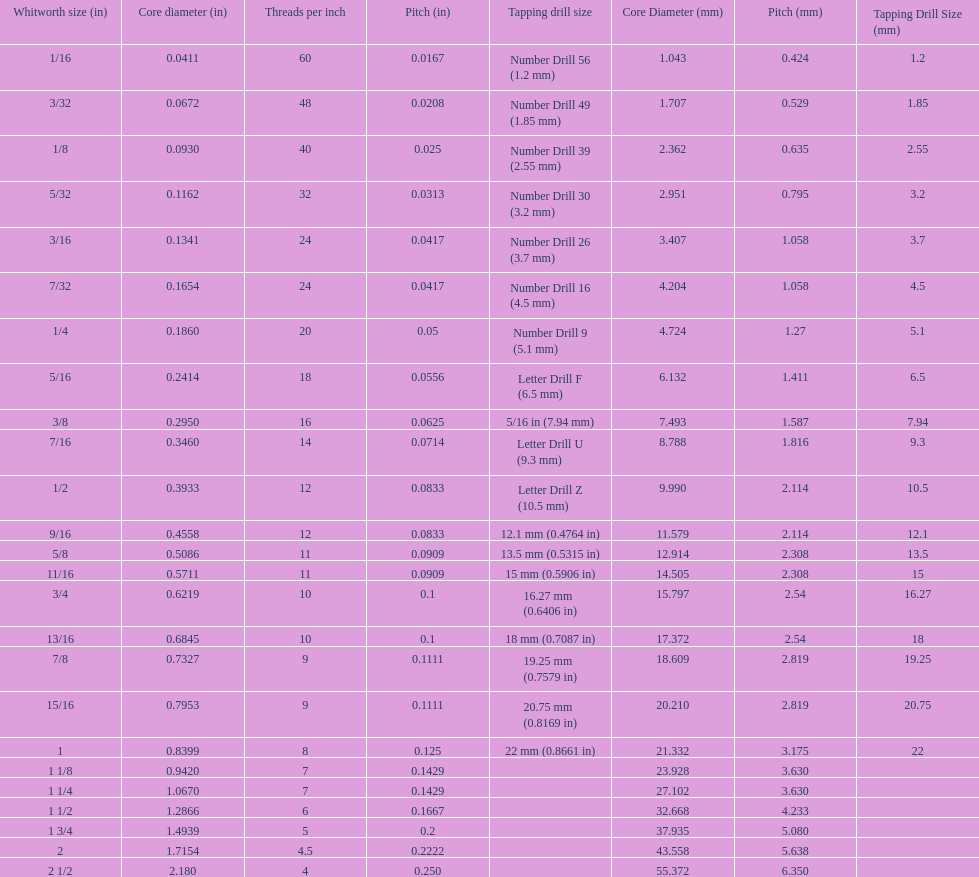What is the least core diameter (in)? 0.0411. 